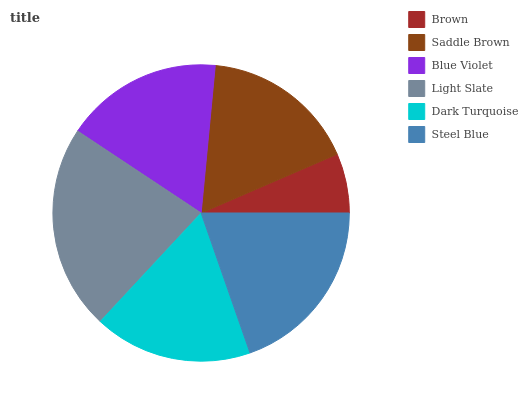Is Brown the minimum?
Answer yes or no. Yes. Is Light Slate the maximum?
Answer yes or no. Yes. Is Saddle Brown the minimum?
Answer yes or no. No. Is Saddle Brown the maximum?
Answer yes or no. No. Is Saddle Brown greater than Brown?
Answer yes or no. Yes. Is Brown less than Saddle Brown?
Answer yes or no. Yes. Is Brown greater than Saddle Brown?
Answer yes or no. No. Is Saddle Brown less than Brown?
Answer yes or no. No. Is Dark Turquoise the high median?
Answer yes or no. Yes. Is Blue Violet the low median?
Answer yes or no. Yes. Is Steel Blue the high median?
Answer yes or no. No. Is Light Slate the low median?
Answer yes or no. No. 